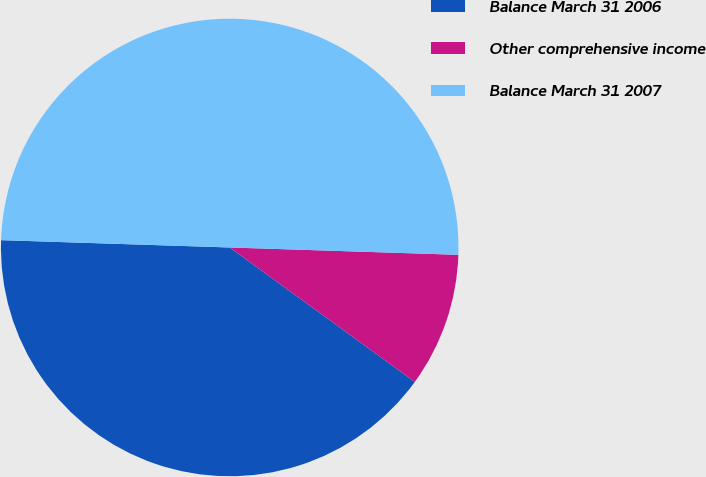<chart> <loc_0><loc_0><loc_500><loc_500><pie_chart><fcel>Balance March 31 2006<fcel>Other comprehensive income<fcel>Balance March 31 2007<nl><fcel>40.51%<fcel>9.49%<fcel>50.0%<nl></chart> 